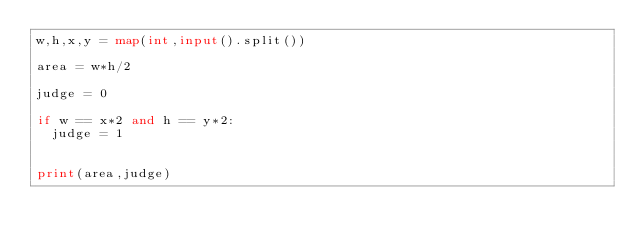Convert code to text. <code><loc_0><loc_0><loc_500><loc_500><_Python_>w,h,x,y = map(int,input().split())

area = w*h/2

judge = 0

if w == x*2 and h == y*2:
  judge = 1
 

print(area,judge)</code> 